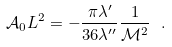Convert formula to latex. <formula><loc_0><loc_0><loc_500><loc_500>\mathcal { A } _ { 0 } L ^ { 2 } = - \frac { \pi \lambda ^ { \prime } } { 3 6 \lambda ^ { \prime \prime } } \frac { 1 } { \mathcal { M } ^ { 2 } } \ .</formula> 